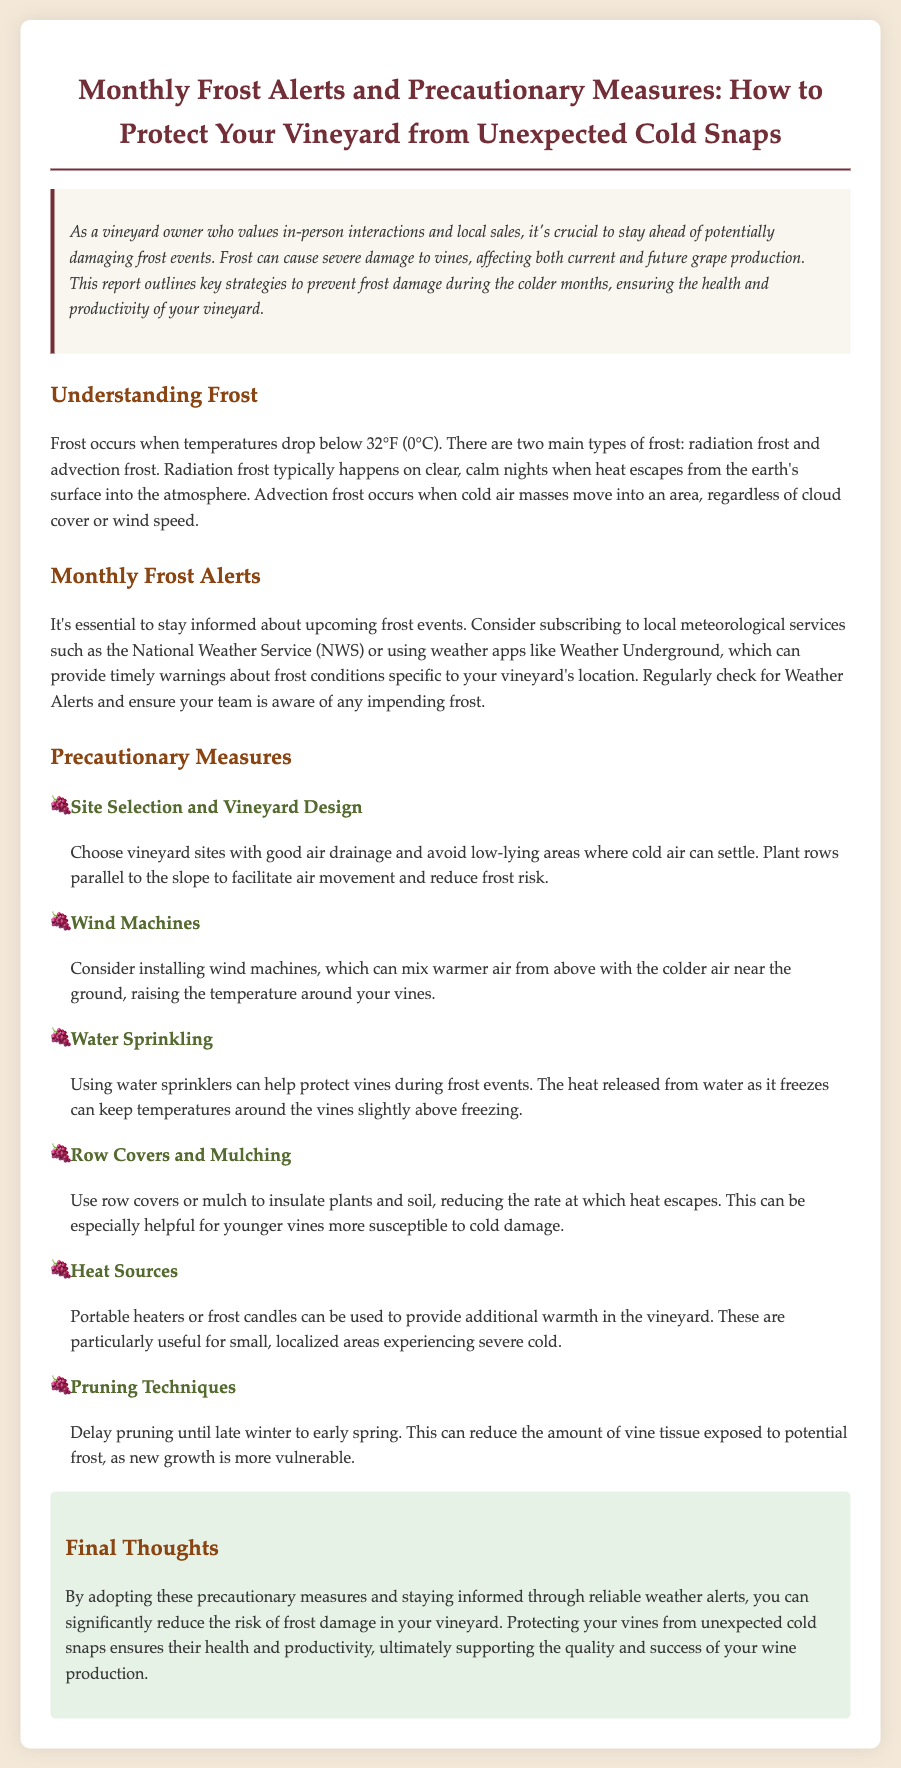What is the main theme of the document? The main theme of the document is about frost alerts and precautionary measures for protecting vineyards from cold snaps.
Answer: frost alerts and precautionary measures What temperature indicates frost conditions? The document states that frost occurs when temperatures drop below 32°F (0°C).
Answer: 32°F (0°C) What type of frost occurs on clear, calm nights? Radiation frost typically happens on clear, calm nights.
Answer: Radiation frost Name one method to protect vines during frost events. The document lists several methods, including using water sprinklers.
Answer: water sprinklers What is one precautionary measure mentioned for vineyard design? The document advises to choose vineyard sites with good air drainage.
Answer: good air drainage What factor can increase the risk of frost in vineyards? Low-lying areas where cold air can settle increase the risk of frost.
Answer: low-lying areas What is the purpose of wind machines in vineyards? Wind machines can mix warmer air from above with colder air near the ground.
Answer: mix warmer air What should you delay until late winter to reduce frost risk? You should delay pruning until late winter to early spring.
Answer: pruning How often should you check for frost alerts? The document suggests regularly checking for Weather Alerts.
Answer: regularly 